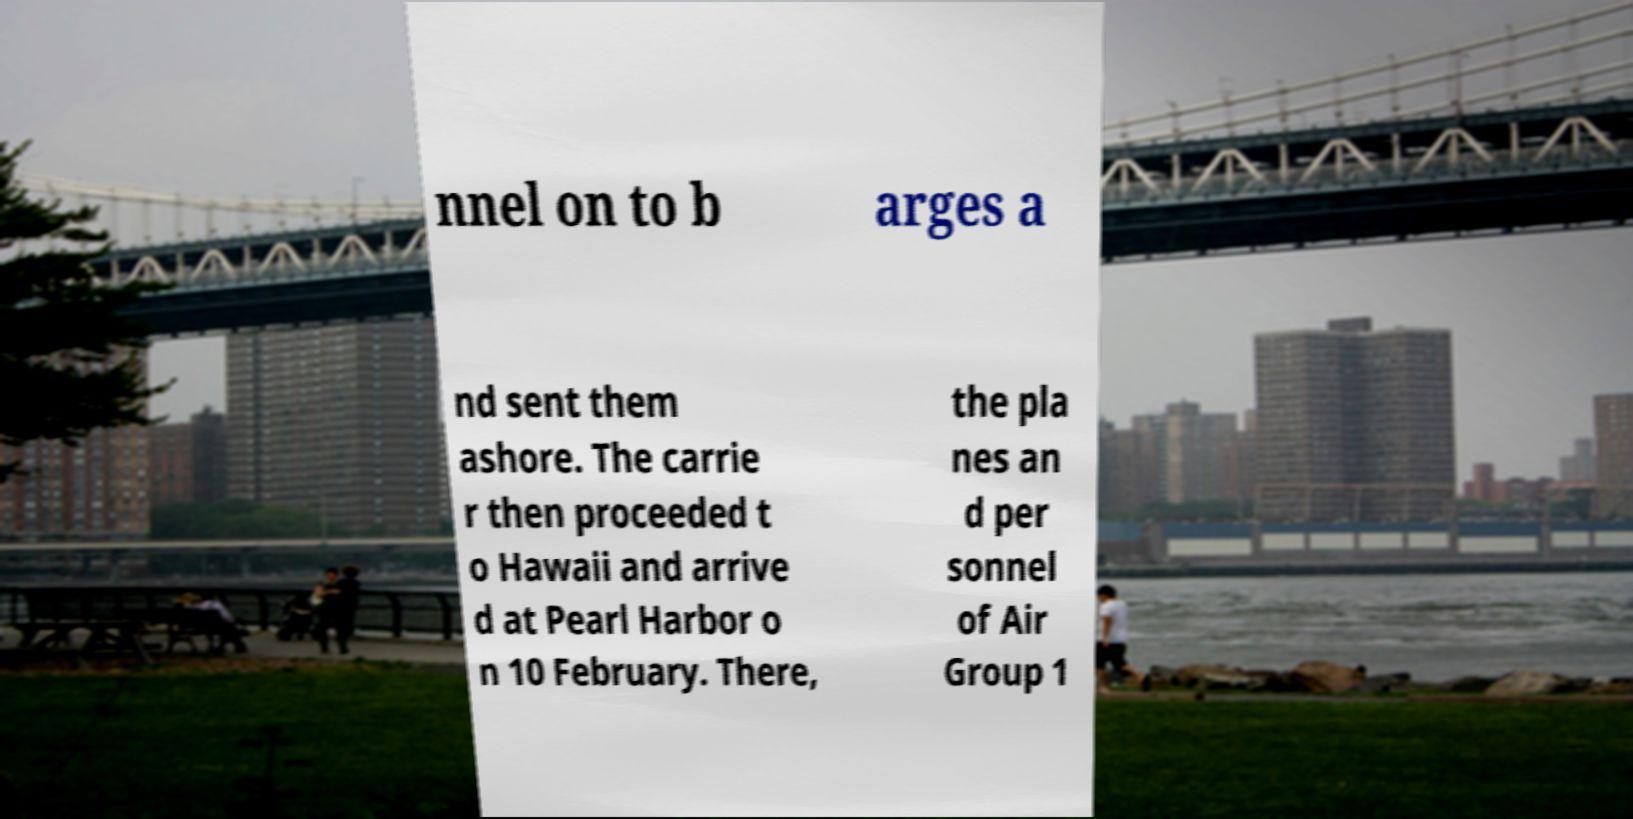There's text embedded in this image that I need extracted. Can you transcribe it verbatim? nnel on to b arges a nd sent them ashore. The carrie r then proceeded t o Hawaii and arrive d at Pearl Harbor o n 10 February. There, the pla nes an d per sonnel of Air Group 1 